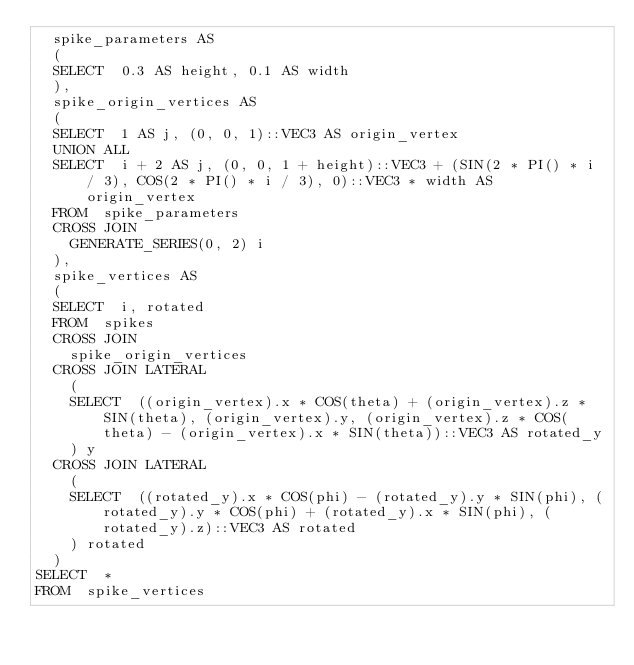Convert code to text. <code><loc_0><loc_0><loc_500><loc_500><_SQL_>	spike_parameters AS
	(
	SELECT	0.3 AS height, 0.1 AS width
	),
	spike_origin_vertices AS
	(
	SELECT	1 AS j, (0, 0, 1)::VEC3 AS origin_vertex
	UNION ALL
	SELECT	i + 2 AS j, (0, 0, 1 + height)::VEC3 + (SIN(2 * PI() * i / 3), COS(2 * PI() * i / 3), 0)::VEC3 * width AS origin_vertex
	FROM	spike_parameters
	CROSS JOIN
		GENERATE_SERIES(0, 2) i
	),
	spike_vertices AS
	(
	SELECT	i, rotated
	FROM	spikes
	CROSS JOIN
		spike_origin_vertices
	CROSS JOIN LATERAL
		(
		SELECT	((origin_vertex).x * COS(theta) + (origin_vertex).z * SIN(theta), (origin_vertex).y, (origin_vertex).z * COS(theta) - (origin_vertex).x * SIN(theta))::VEC3 AS rotated_y
		) y
	CROSS JOIN LATERAL
		(
		SELECT	((rotated_y).x * COS(phi) - (rotated_y).y * SIN(phi), (rotated_y).y * COS(phi) + (rotated_y).x * SIN(phi), (rotated_y).z)::VEC3 AS rotated
		) rotated
	)
SELECT	*
FROM	spike_vertices

</code> 